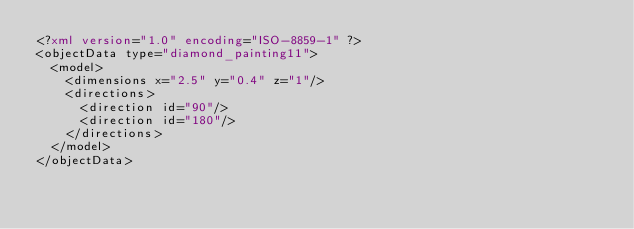<code> <loc_0><loc_0><loc_500><loc_500><_XML_><?xml version="1.0" encoding="ISO-8859-1" ?><objectData type="diamond_painting11">
  <model>
    <dimensions x="2.5" y="0.4" z="1"/>
    <directions>
      <direction id="90"/>
      <direction id="180"/>
    </directions>
  </model>
</objectData></code> 